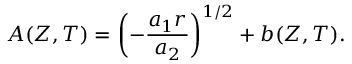<formula> <loc_0><loc_0><loc_500><loc_500>A ( Z , T ) = \left ( - \frac { a _ { 1 } r } { a _ { 2 } } \right ) ^ { 1 / 2 } + b ( Z , T ) .</formula> 